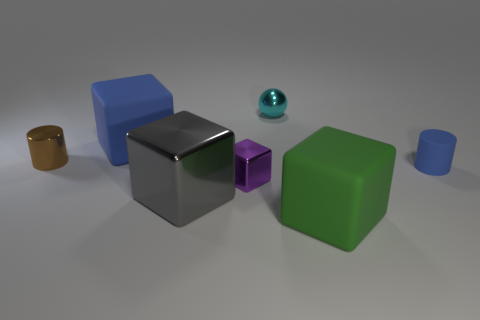Subtract all small purple blocks. How many blocks are left? 3 Add 1 blue rubber blocks. How many objects exist? 8 Subtract all cylinders. How many objects are left? 5 Subtract all gray blocks. How many blocks are left? 3 Subtract 1 cylinders. How many cylinders are left? 1 Subtract 0 brown balls. How many objects are left? 7 Subtract all blue blocks. Subtract all red cylinders. How many blocks are left? 3 Subtract all yellow spheres. How many red blocks are left? 0 Subtract all green rubber cubes. Subtract all cylinders. How many objects are left? 4 Add 3 big matte things. How many big matte things are left? 5 